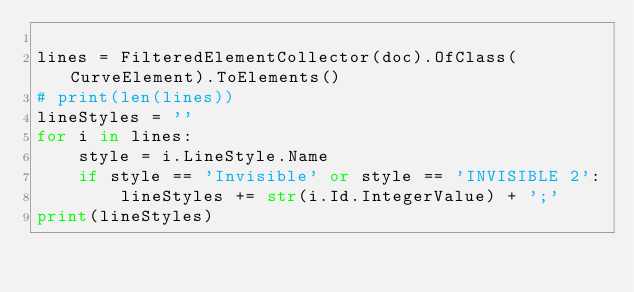Convert code to text. <code><loc_0><loc_0><loc_500><loc_500><_Python_>
lines = FilteredElementCollector(doc).OfClass(CurveElement).ToElements()
# print(len(lines))
lineStyles = ''
for i in lines:
    style = i.LineStyle.Name
    if style == 'Invisible' or style == 'INVISIBLE 2':
        lineStyles += str(i.Id.IntegerValue) + ';'
print(lineStyles)




</code> 